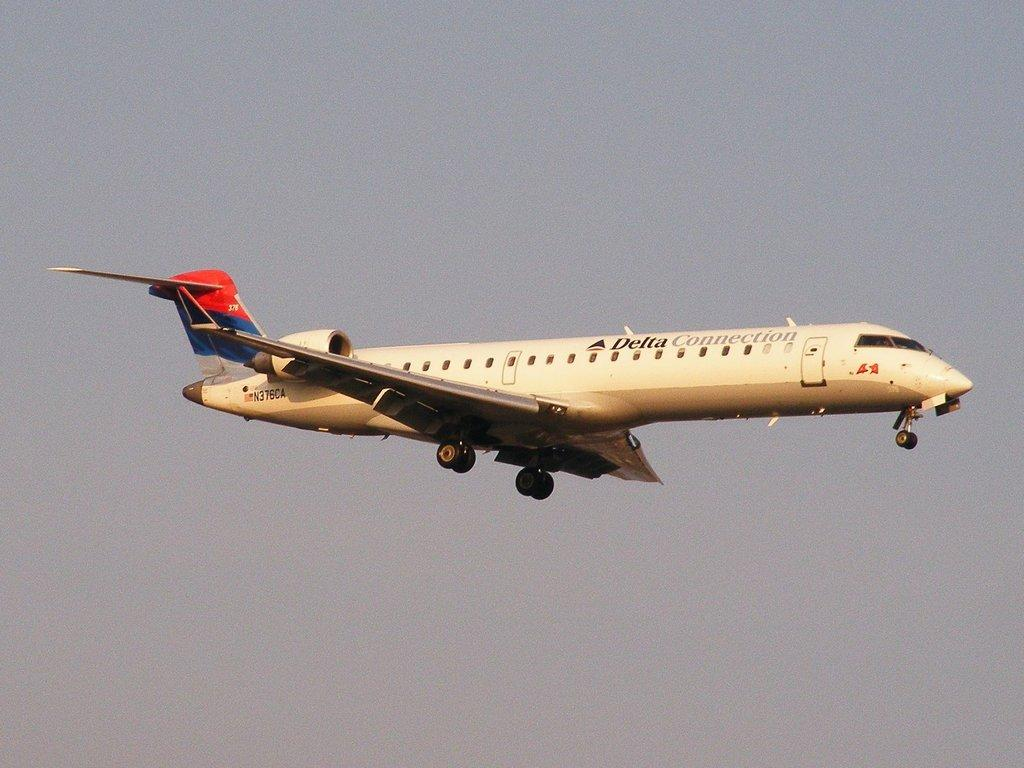<image>
Offer a succinct explanation of the picture presented. a plane with the words 'delta connection' on the side of it 